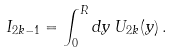<formula> <loc_0><loc_0><loc_500><loc_500>I _ { 2 k - 1 } = \int _ { 0 } ^ { R } d y \, U _ { 2 k } ( y ) \, .</formula> 